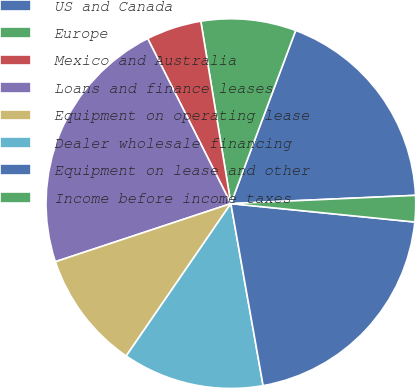Convert chart. <chart><loc_0><loc_0><loc_500><loc_500><pie_chart><fcel>US and Canada<fcel>Europe<fcel>Mexico and Australia<fcel>Loans and finance leases<fcel>Equipment on operating lease<fcel>Dealer wholesale financing<fcel>Equipment on lease and other<fcel>Income before income taxes<nl><fcel>18.59%<fcel>8.3%<fcel>4.83%<fcel>22.66%<fcel>10.33%<fcel>12.37%<fcel>20.62%<fcel>2.3%<nl></chart> 